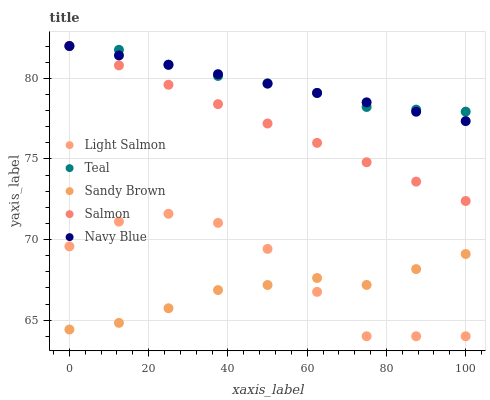Does Sandy Brown have the minimum area under the curve?
Answer yes or no. Yes. Does Teal have the maximum area under the curve?
Answer yes or no. Yes. Does Light Salmon have the minimum area under the curve?
Answer yes or no. No. Does Light Salmon have the maximum area under the curve?
Answer yes or no. No. Is Navy Blue the smoothest?
Answer yes or no. Yes. Is Light Salmon the roughest?
Answer yes or no. Yes. Is Sandy Brown the smoothest?
Answer yes or no. No. Is Sandy Brown the roughest?
Answer yes or no. No. Does Light Salmon have the lowest value?
Answer yes or no. Yes. Does Sandy Brown have the lowest value?
Answer yes or no. No. Does Navy Blue have the highest value?
Answer yes or no. Yes. Does Light Salmon have the highest value?
Answer yes or no. No. Is Sandy Brown less than Salmon?
Answer yes or no. Yes. Is Teal greater than Sandy Brown?
Answer yes or no. Yes. Does Sandy Brown intersect Light Salmon?
Answer yes or no. Yes. Is Sandy Brown less than Light Salmon?
Answer yes or no. No. Is Sandy Brown greater than Light Salmon?
Answer yes or no. No. Does Sandy Brown intersect Salmon?
Answer yes or no. No. 